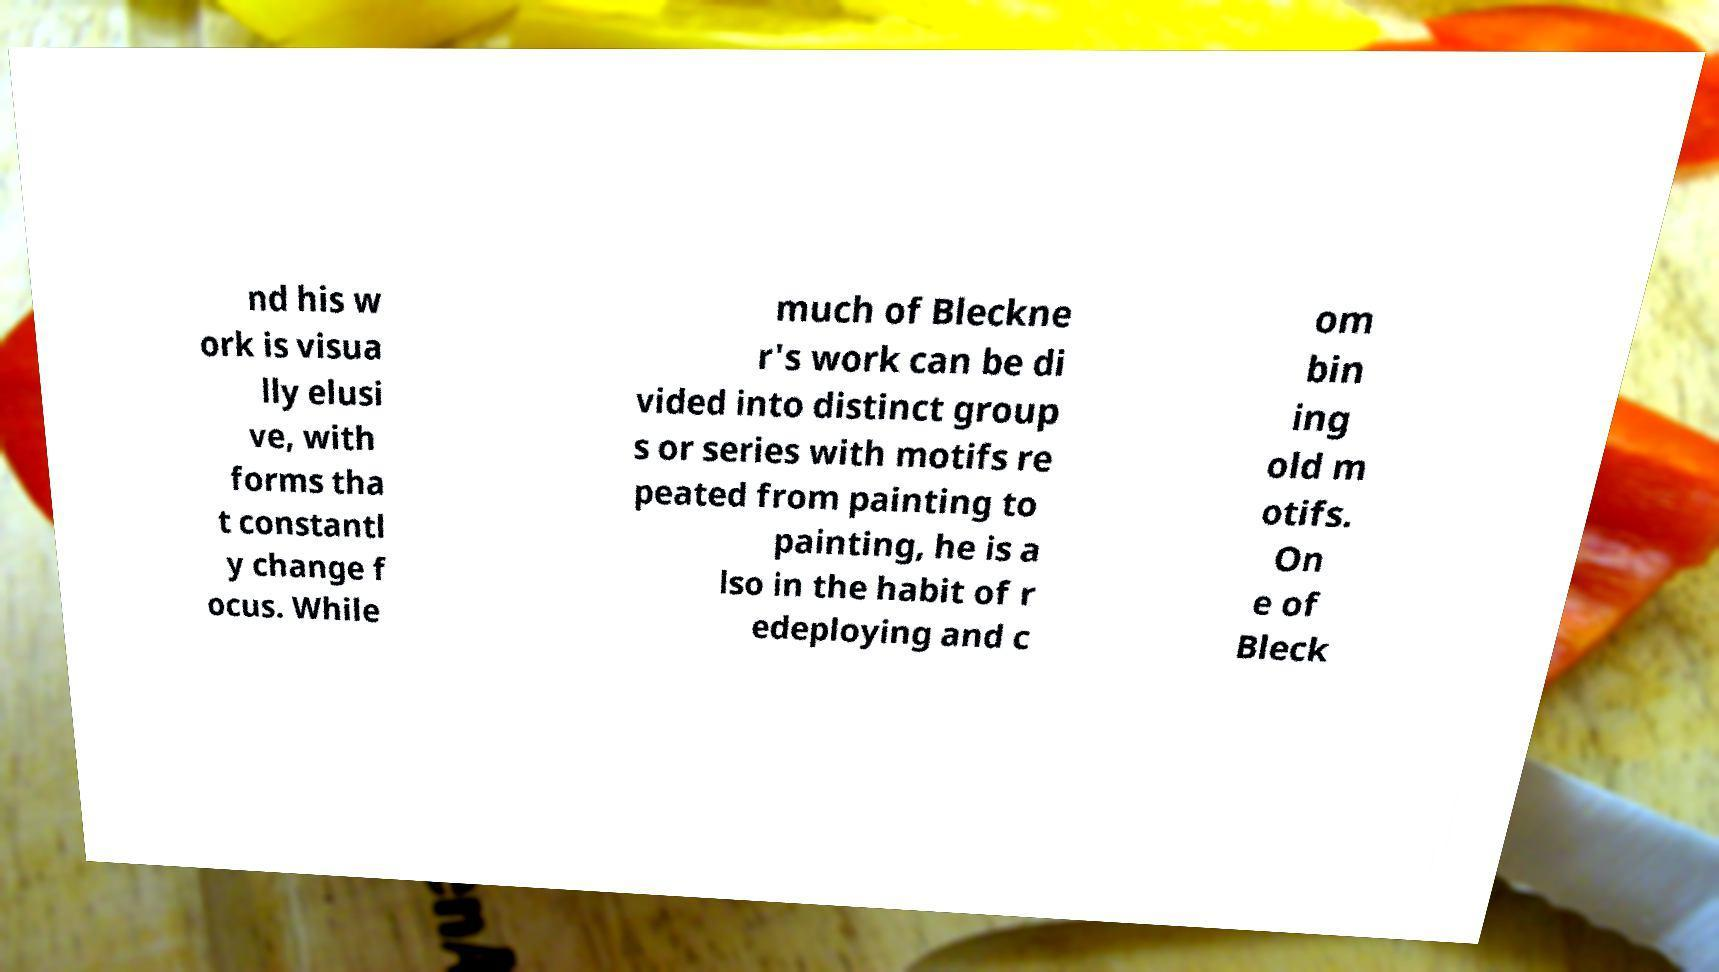Can you read and provide the text displayed in the image?This photo seems to have some interesting text. Can you extract and type it out for me? nd his w ork is visua lly elusi ve, with forms tha t constantl y change f ocus. While much of Bleckne r's work can be di vided into distinct group s or series with motifs re peated from painting to painting, he is a lso in the habit of r edeploying and c om bin ing old m otifs. On e of Bleck 